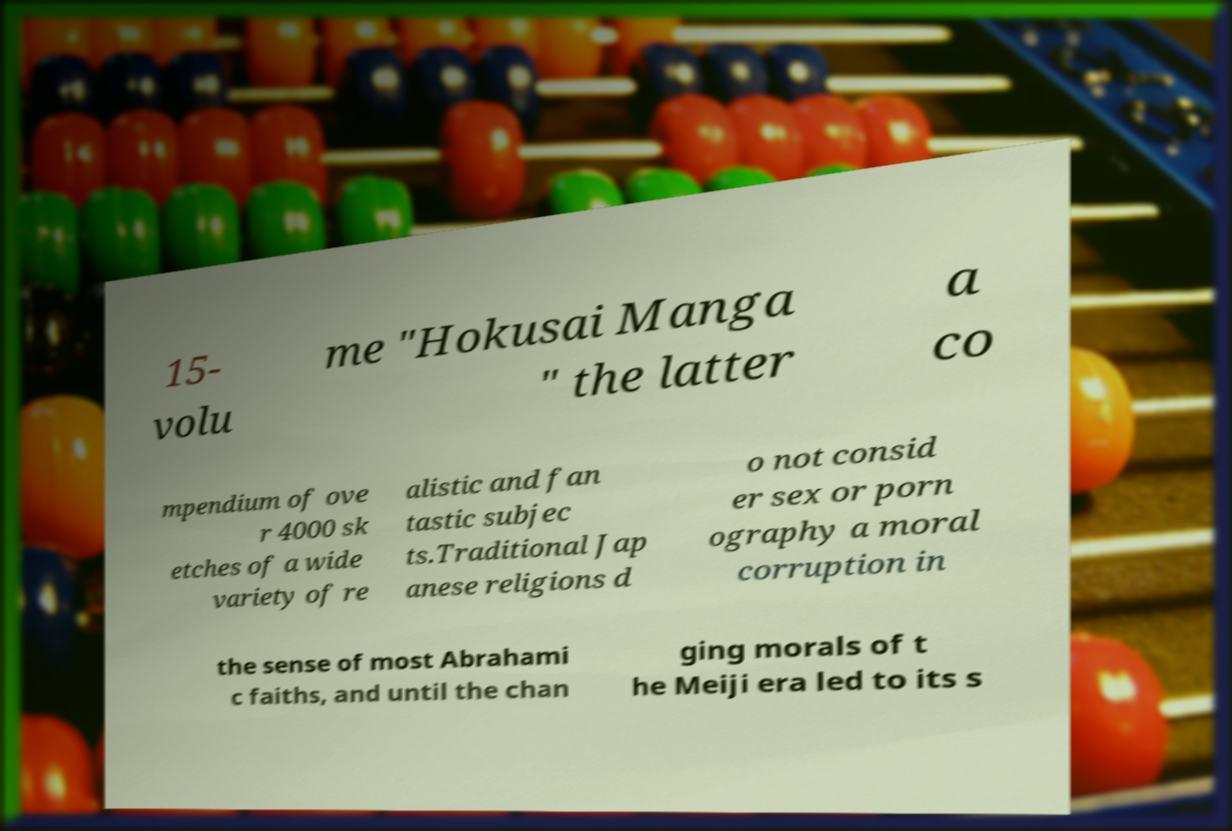Please identify and transcribe the text found in this image. 15- volu me "Hokusai Manga " the latter a co mpendium of ove r 4000 sk etches of a wide variety of re alistic and fan tastic subjec ts.Traditional Jap anese religions d o not consid er sex or porn ography a moral corruption in the sense of most Abrahami c faiths, and until the chan ging morals of t he Meiji era led to its s 